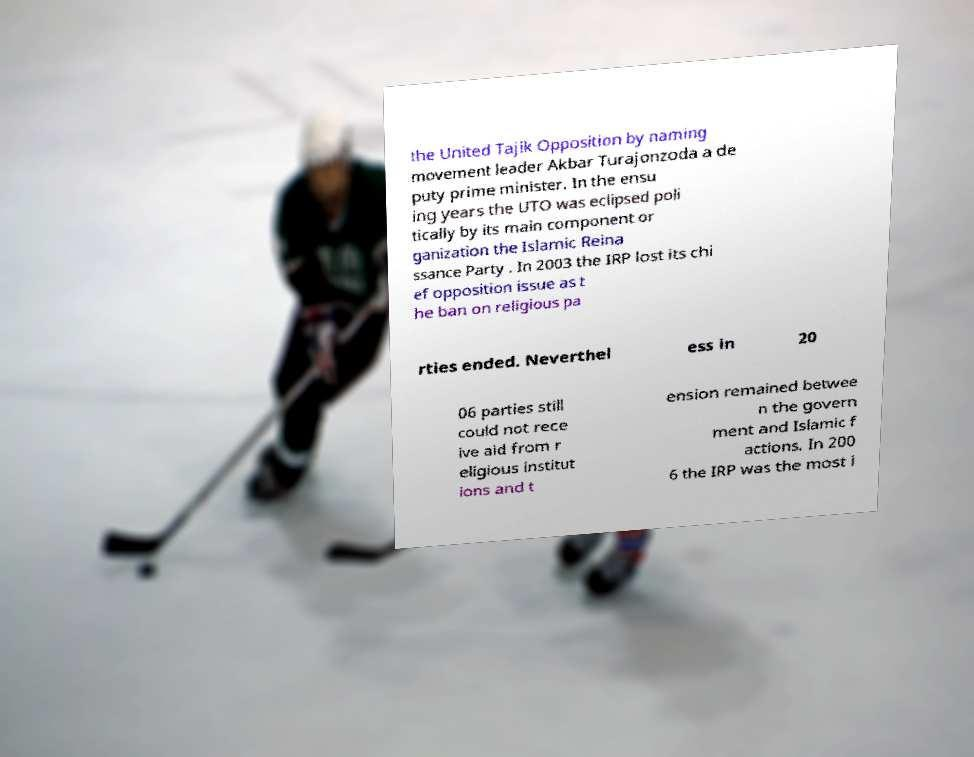What messages or text are displayed in this image? I need them in a readable, typed format. the United Tajik Opposition by naming movement leader Akbar Turajonzoda a de puty prime minister. In the ensu ing years the UTO was eclipsed poli tically by its main component or ganization the Islamic Reina ssance Party . In 2003 the IRP lost its chi ef opposition issue as t he ban on religious pa rties ended. Neverthel ess in 20 06 parties still could not rece ive aid from r eligious institut ions and t ension remained betwee n the govern ment and Islamic f actions. In 200 6 the IRP was the most i 